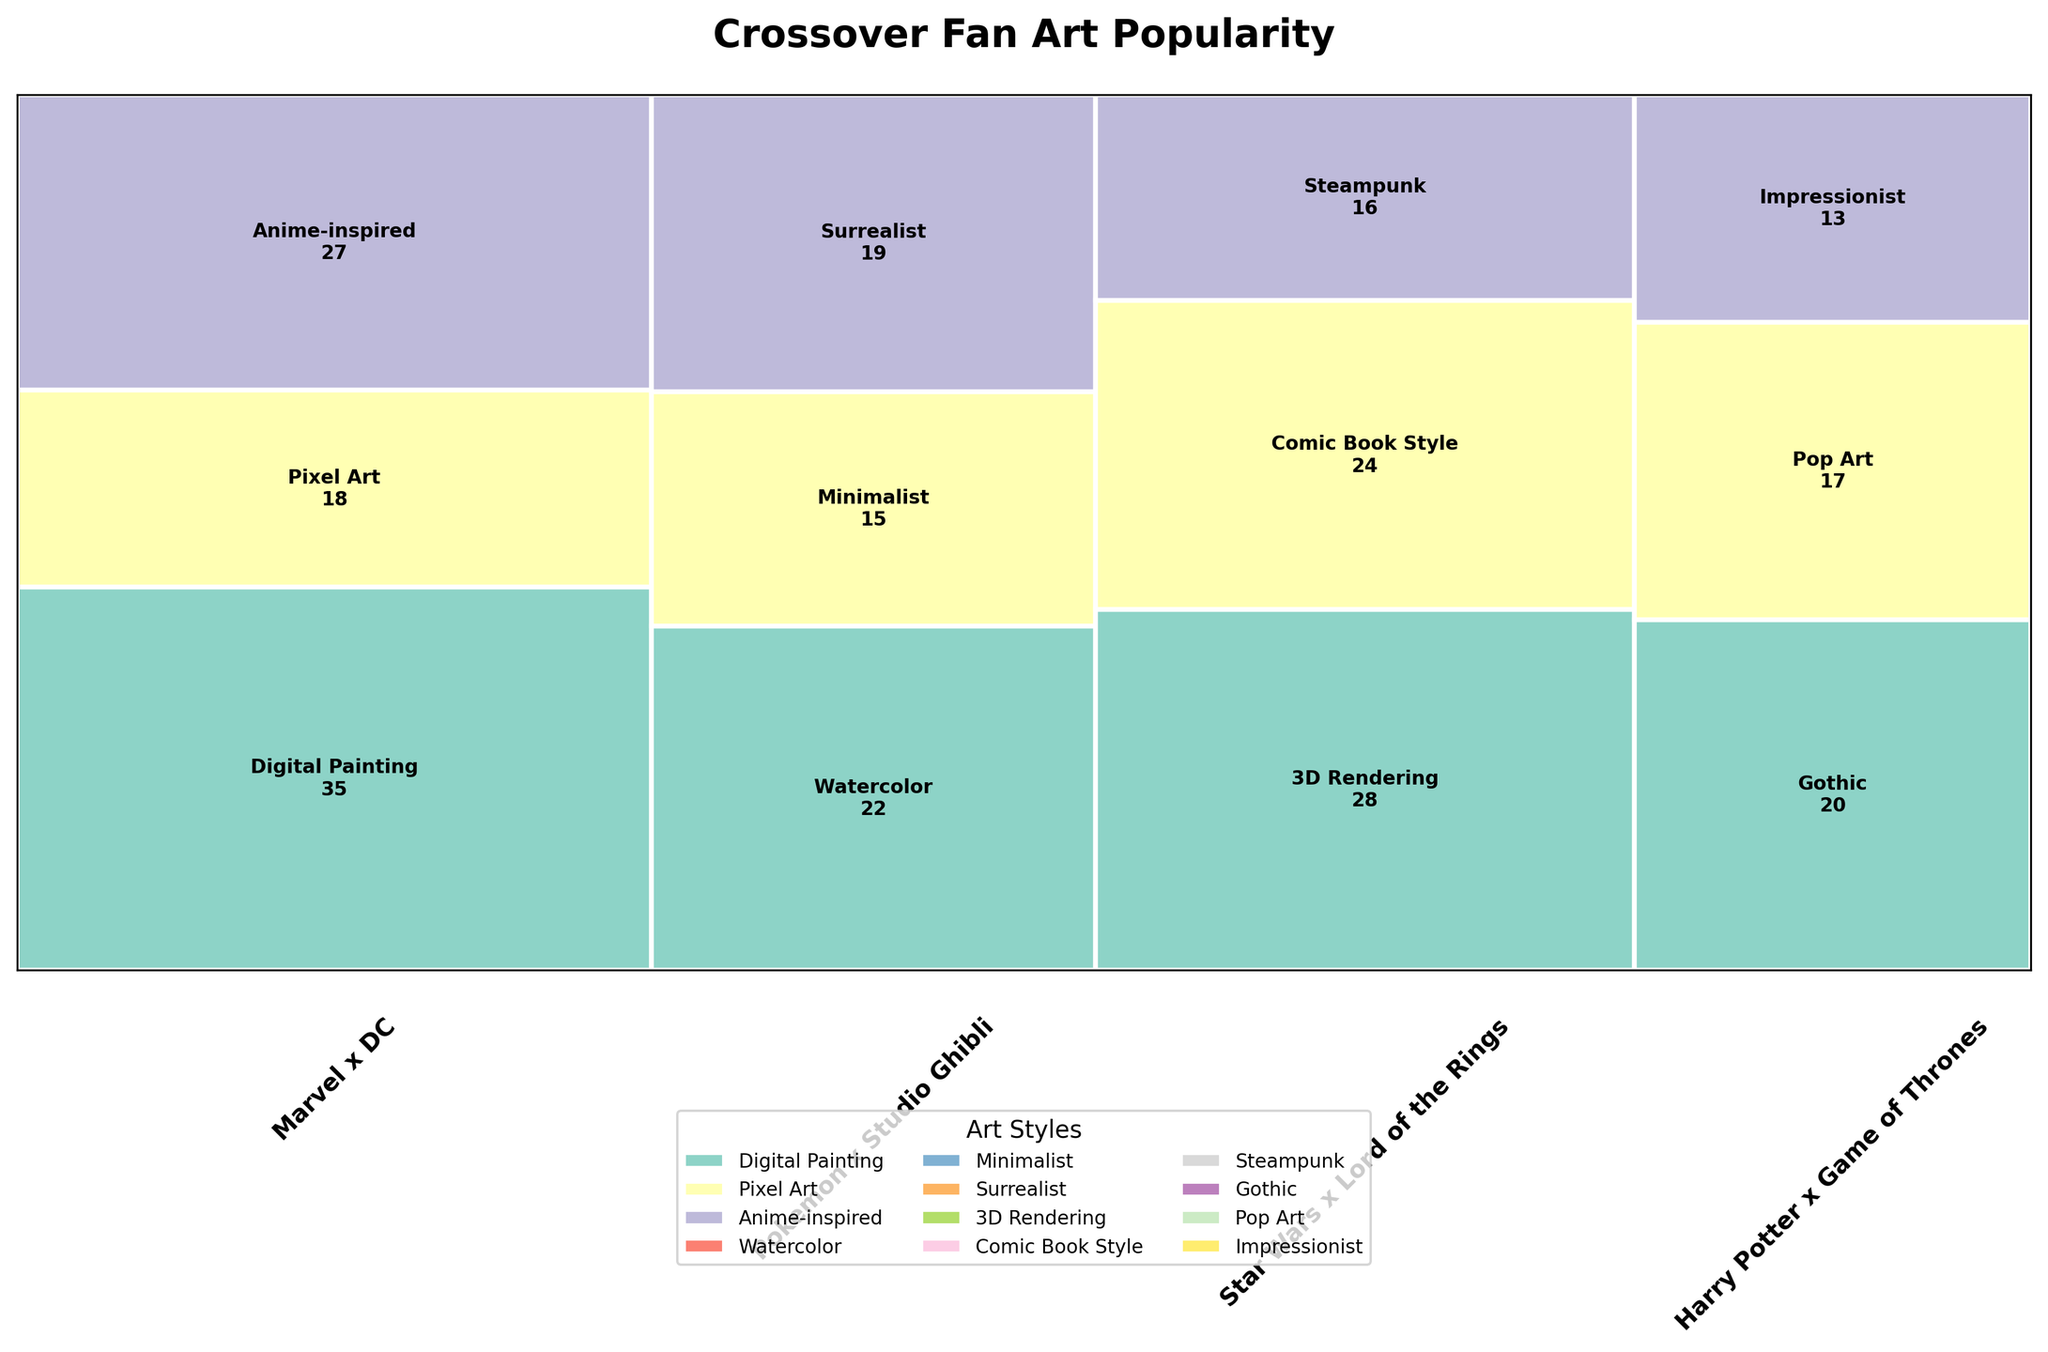What is the title of the figure? The title is typically located at the top of the plot. In this case, it's clearly stated in the figure.
Answer: Crossover Fan Art Popularity Which franchise combination has the highest total popularity? By checking the widths of the segments for each franchise, we see that "Marvel x DC" has the largest width, indicating it has the highest total popularity.
Answer: Marvel x DC Which art style is most popular in the "Pokemon x Studio Ghibli" crossover? For "Pokemon x Studio Ghibli," the art style with the largest height segment in its respective column indicates the highest popularity. Watercolor has the largest height in this franchise combination.
Answer: Watercolor How does the popularity of "Pixel Art" in "Marvel x DC" compare to "Impressionist" in "Harry Potter x Game of Thrones"? Check the height of the "Pixel Art" segment under "Marvel x DC" and compare it to the "Impressionist" segment under "Harry Potter x Game of Thrones". Pixel Art has higher popularity than Impressionist.
Answer: Pixel Art is more popular What's the least popular art style across all franchises combined? Find the art style with the smallest height segment across all franchise columns. "Minimalist" within "Pokemon x Studio Ghibli" appears to be the least popular.
Answer: Minimalist What is the combined popularity of "Steampunk" in "Star Wars x Lord of the Rings" and "Gothic" in "Harry Potter x Game of Thrones"? Steampunk has a popularity of 16 and Gothic has a popularity of 20. Their combined total is 16 + 20 = 36.
Answer: 36 Which franchise combination has more total popularity: "Harry Potter x Game of Thrones" or "Pokemon x Studio Ghibli"? Evaluate the widths of the columns associated with these franchises. The total width for "Pokemon x Studio Ghibli" appears larger than for "Harry Potter x Game of Thrones".
Answer: Pokemon x Studio Ghibli What is the total number of unique art styles used in the plot? Count the unique art styles listed in the legend at the bottom. There are eight unique art styles.
Answer: 8 What's the most popular art style in "Star Wars x Lord of the Rings"? Evaluate the height of different segments in the "Star Wars x Lord of the Rings" column. "3D Rendering" has the highest segment.
Answer: 3D Rendering Which franchise has a more even distribution of popularity among its art styles: "Star Wars x Lord of the Rings" or "Pokemon x Studio Ghibli"? Compare the relative uniformity of the heights of the segments within each franchise. "Pokemon x Studio Ghibli" has segments that are more evenly distributed in height than "Star Wars x Lord of the Rings".
Answer: Pokemon x Studio Ghibli 